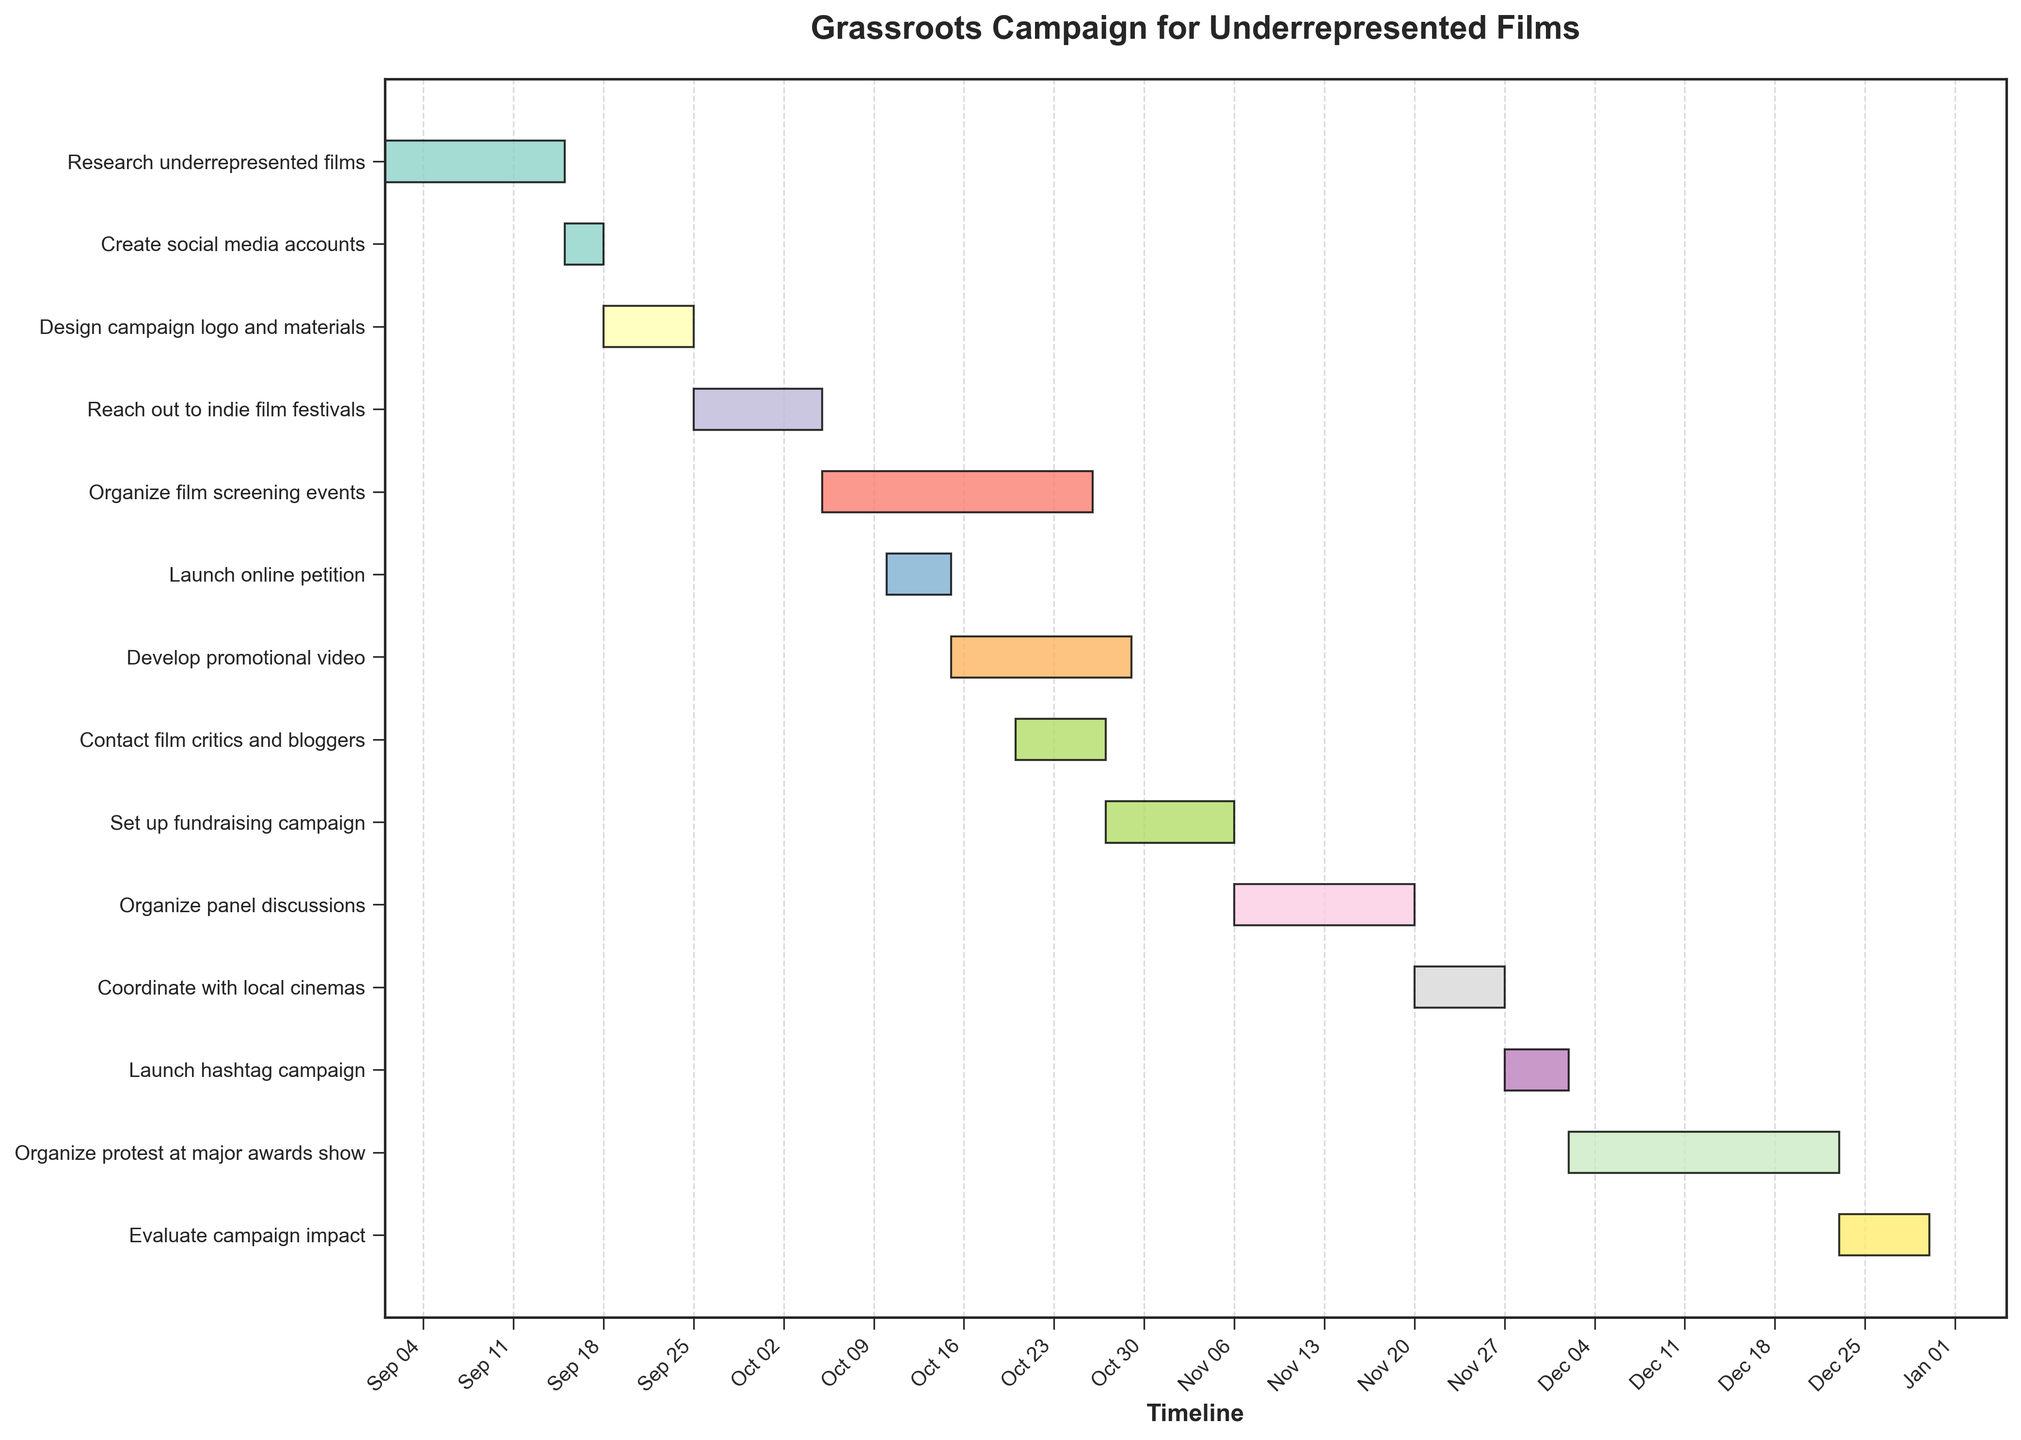What is the title of the chart? The title of the chart is located at the top of the figure. It is usually bold and larger than other text elements. The title provides context or a summary of the chart's purpose.
Answer: Grassroots Campaign for Underrepresented Films Which task starts first in the campaign? To find the first task, look for the earliest date on the horizontal axis and find the corresponding task bar that starts on that date. This task is at the top of the chart, as tasks are sorted by start date.
Answer: Research underrepresented films What is the duration of the "Organize protest at major awards show" task? Find the bar corresponding to "Organize protest at major awards show" and measure its length along the timeline axis. The duration is noted in the data label or by counting the days between its start and end points.
Answer: 21 days During which date range does the "Develop promotional video" task occur? Locate the bar for "Develop promotional video" and note its start and end dates from the horizontal axis.
Answer: Oct 15 to Oct 29 How long is the "Set up fundraising campaign" task? Examine the length of the bar corresponding to "Set up fundraising campaign" and note the number of days it spans on the timeline.
Answer: 10 days Which task overlaps with the "Launch online petition"? Identify the start and end dates of "Launch online petition," then look for other task bars that share any part of this date range.
Answer: Organize film screening events How many tasks begin after November 1st? Count the number of task bars whose start dates are later than November 1st by checking the horizontal axis for dates.
Answer: 6 tasks What is the cumulative duration of all tasks starting in October? Identify tasks that start in October, sum their durations. Tasks are "Organize film screening events," "Launch online petition," "Develop promotional video," "Contact film critics and bloggers." Add durations: 21 + 5 + 14 + 7 days.
Answer: 47 days Which task has the shortest duration and what is it? Compare the duration of all task bars and identify the shortest one.
Answer: Create social media accounts with 3 days How does the task "Coordinate with local cinemas" relate time-wise to "Organize protest at major awards show"? Locate the start and end dates of both tasks to understand their relationship. "Coordinate with local cinemas" starts and ends before "Organize protest at major awards show."
Answer: It ends before the protest begins 